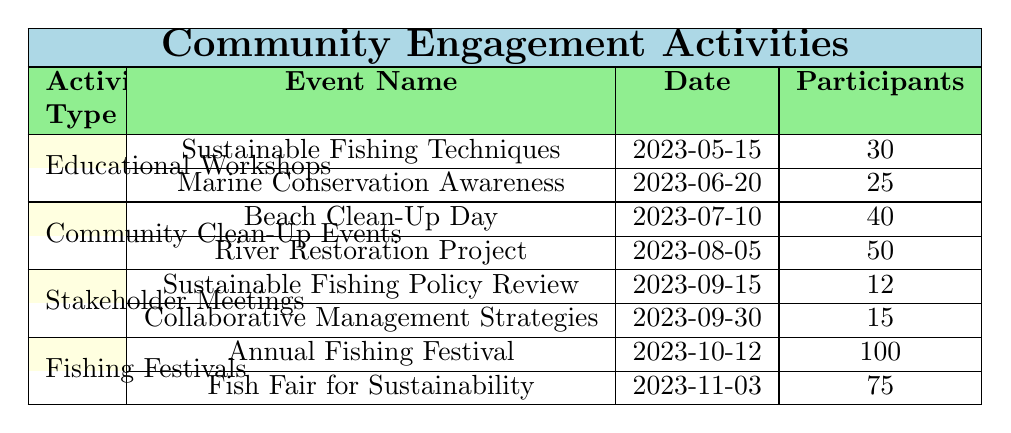What is the total number of participants in the Educational Workshops? There are two workshops listed under Educational Workshops. The number of participants for the "Sustainable Fishing Techniques" workshop is 30, and for the "Marine Conservation Awareness" workshop, it is 25. To find the total, we add the two values: 30 + 25 = 55.
Answer: 55 Which event had the highest participation? The table includes various activities with different participation numbers. The "Annual Fishing Festival" has the highest participation with 100 participants, compared to other events with 75, 50, 40, 30, and 25 participants.
Answer: Annual Fishing Festival Did the "River Restoration Project" have more participants than the "Sustainable Fishing Policy Review"? The "River Restoration Project" had 50 participants, while the "Sustainable Fishing Policy Review" had 12 participants. Comparing these two values, 50 is greater than 12, thus the statement is true.
Answer: Yes What is the average number of participants across all events? First, we find the total number of participants by adding all the values: 30 + 25 + 40 + 50 + 12 + 15 + 100 + 75 = 352. There are a total of 8 events. To find the average, we divide the total (352) by the number of events (8), giving us 352 / 8 = 44.
Answer: 44 How many events are there focusing on educational workshops? The table shows a section for Educational Workshops, which includes two specific workshops: "Sustainable Fishing Techniques" and "Marine Conservation Awareness." Therefore, there are two events in this category.
Answer: 2 